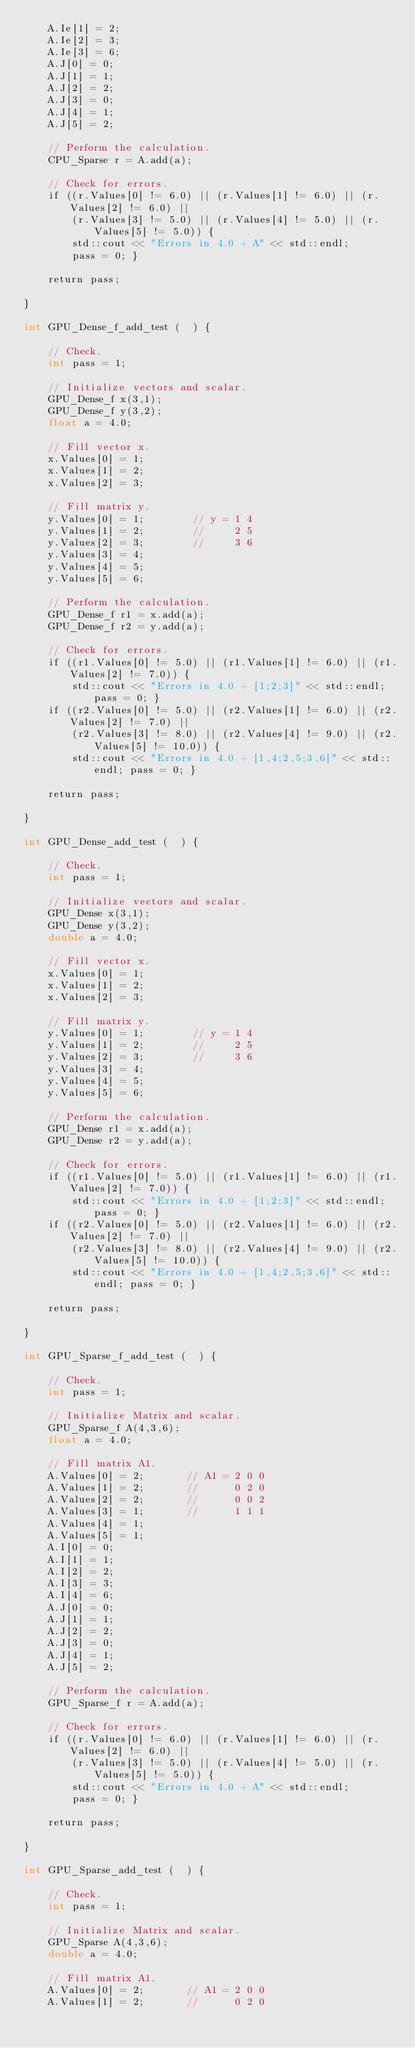Convert code to text. <code><loc_0><loc_0><loc_500><loc_500><_Cuda_>    A.Ie[1] = 2;
    A.Ie[2] = 3;
    A.Ie[3] = 6;
    A.J[0] = 0;
    A.J[1] = 1;
    A.J[2] = 2;
    A.J[3] = 0;
    A.J[4] = 1;
    A.J[5] = 2;

    // Perform the calculation.
    CPU_Sparse r = A.add(a);
    
    // Check for errors.
    if ((r.Values[0] != 6.0) || (r.Values[1] != 6.0) || (r.Values[2] != 6.0) || 
        (r.Values[3] != 5.0) || (r.Values[4] != 5.0) || (r.Values[5] != 5.0)) {
        std::cout << "Errors in 4.0 + A" << std::endl;
        pass = 0; }
    
    return pass;

}

int GPU_Dense_f_add_test (  ) {

    // Check.
    int pass = 1;

    // Initialize vectors and scalar.
    GPU_Dense_f x(3,1);
    GPU_Dense_f y(3,2);
    float a = 4.0;

    // Fill vector x.
    x.Values[0] = 1;
    x.Values[1] = 2;
    x.Values[2] = 3;

    // Fill matrix y.
    y.Values[0] = 1;        // y = 1 4
    y.Values[1] = 2;        //     2 5
    y.Values[2] = 3;        //     3 6
    y.Values[3] = 4;
    y.Values[4] = 5;
    y.Values[5] = 6;

    // Perform the calculation.
    GPU_Dense_f r1 = x.add(a);
    GPU_Dense_f r2 = y.add(a);

    // Check for errors.
    if ((r1.Values[0] != 5.0) || (r1.Values[1] != 6.0) || (r1.Values[2] != 7.0)) {
        std::cout << "Errors in 4.0 + [1;2;3]" << std::endl; pass = 0; }
    if ((r2.Values[0] != 5.0) || (r2.Values[1] != 6.0) || (r2.Values[2] != 7.0) ||
        (r2.Values[3] != 8.0) || (r2.Values[4] != 9.0) || (r2.Values[5] != 10.0)) {
        std::cout << "Errors in 4.0 + [1,4;2,5;3,6]" << std::endl; pass = 0; }
    
    return pass;

}

int GPU_Dense_add_test (  ) {

    // Check.
    int pass = 1;

    // Initialize vectors and scalar.
    GPU_Dense x(3,1);
    GPU_Dense y(3,2);
    double a = 4.0;

    // Fill vector x.
    x.Values[0] = 1;
    x.Values[1] = 2;
    x.Values[2] = 3;

    // Fill matrix y.
    y.Values[0] = 1;        // y = 1 4
    y.Values[1] = 2;        //     2 5
    y.Values[2] = 3;        //     3 6
    y.Values[3] = 4;
    y.Values[4] = 5;
    y.Values[5] = 6;

    // Perform the calculation.
    GPU_Dense r1 = x.add(a);
    GPU_Dense r2 = y.add(a);

    // Check for errors.
    if ((r1.Values[0] != 5.0) || (r1.Values[1] != 6.0) || (r1.Values[2] != 7.0)) {
        std::cout << "Errors in 4.0 + [1;2;3]" << std::endl; pass = 0; }
    if ((r2.Values[0] != 5.0) || (r2.Values[1] != 6.0) || (r2.Values[2] != 7.0) ||
        (r2.Values[3] != 8.0) || (r2.Values[4] != 9.0) || (r2.Values[5] != 10.0)) {
        std::cout << "Errors in 4.0 + [1,4;2,5;3,6]" << std::endl; pass = 0; }
    
    return pass;

}

int GPU_Sparse_f_add_test (  ) {

    // Check.
    int pass = 1;

    // Initialize Matrix and scalar.
    GPU_Sparse_f A(4,3,6);
    float a = 4.0;
        
    // Fill matrix A1.
    A.Values[0] = 2;       // A1 = 2 0 0
    A.Values[1] = 2;       //      0 2 0
    A.Values[2] = 2;       //      0 0 2
    A.Values[3] = 1;       //      1 1 1
    A.Values[4] = 1;
    A.Values[5] = 1;
    A.I[0] = 0;
    A.I[1] = 1;
    A.I[2] = 2;
    A.I[3] = 3;
    A.I[4] = 6;
    A.J[0] = 0;
    A.J[1] = 1;
    A.J[2] = 2;
    A.J[3] = 0;
    A.J[4] = 1;
    A.J[5] = 2;

    // Perform the calculation.
    GPU_Sparse_f r = A.add(a);
    
    // Check for errors.
    if ((r.Values[0] != 6.0) || (r.Values[1] != 6.0) || (r.Values[2] != 6.0) || 
        (r.Values[3] != 5.0) || (r.Values[4] != 5.0) || (r.Values[5] != 5.0)) {
        std::cout << "Errors in 4.0 + A" << std::endl;
        pass = 0; }
    
    return pass;

}

int GPU_Sparse_add_test (  ) {

    // Check.
    int pass = 1;

    // Initialize Matrix and scalar.
    GPU_Sparse A(4,3,6);
    double a = 4.0;
        
    // Fill matrix A1.
    A.Values[0] = 2;       // A1 = 2 0 0
    A.Values[1] = 2;       //      0 2 0</code> 